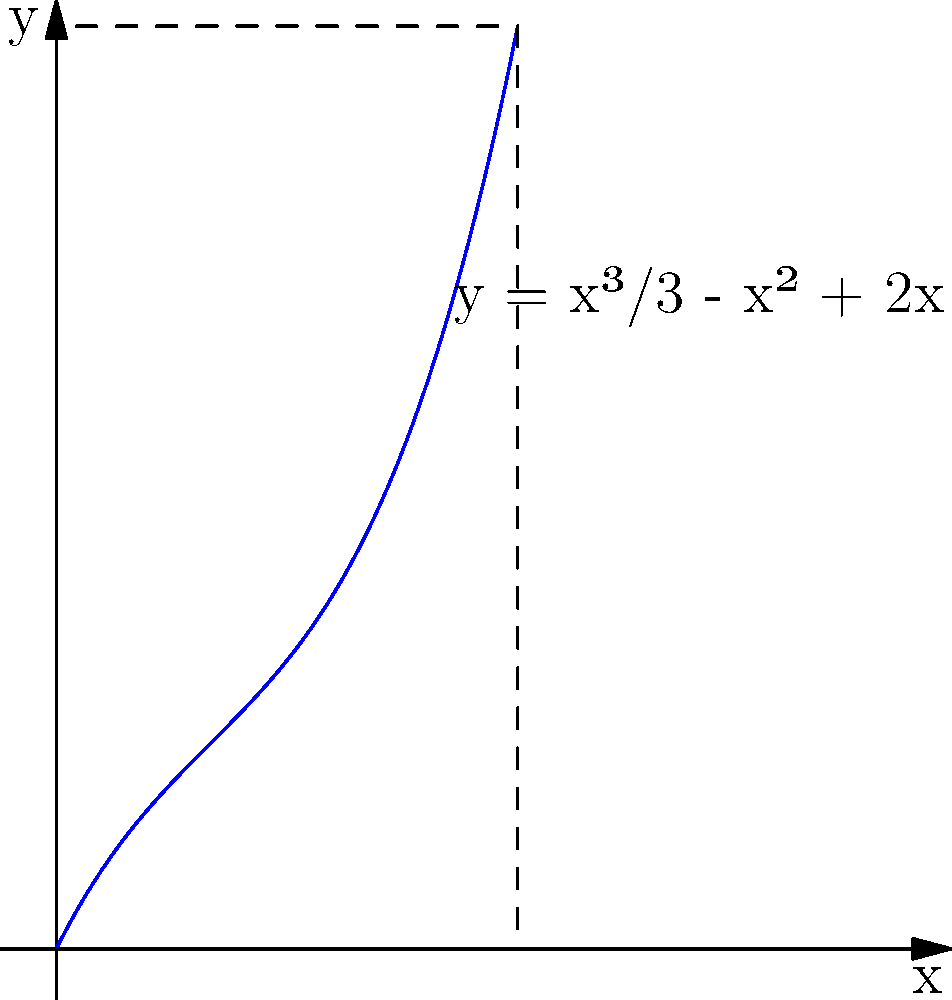Given the function $f(x) = \frac{x^3}{3} - x^2 + 2x$ shown in the graph, calculate the area under the curve from $x=0$ to $x=3$ using integration techniques. To find the area under the curve, we need to integrate the function from $x=0$ to $x=3$. Here's the step-by-step process:

1) Set up the definite integral:
   $$\int_0^3 (\frac{x^3}{3} - x^2 + 2x) dx$$

2) Integrate the function:
   $$\left[\frac{x^4}{12} - \frac{x^3}{3} + x^2\right]_0^3$$

3) Evaluate the integral at the upper and lower bounds:
   Upper bound (x=3): $\frac{3^4}{12} - \frac{3^3}{3} + 3^2 = \frac{81}{12} - 9 + 9 = \frac{81}{12} = 6.75$
   Lower bound (x=0): $\frac{0^4}{12} - \frac{0^3}{3} + 0^2 = 0$

4) Subtract the lower bound result from the upper bound result:
   $6.75 - 0 = 6.75$

Therefore, the area under the curve from $x=0$ to $x=3$ is 6.75 square units.
Answer: $6.75$ square units 